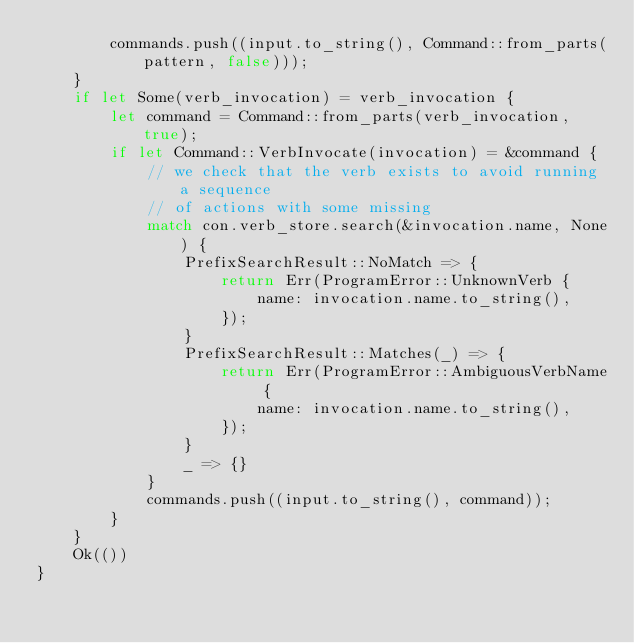<code> <loc_0><loc_0><loc_500><loc_500><_Rust_>        commands.push((input.to_string(), Command::from_parts(pattern, false)));
    }
    if let Some(verb_invocation) = verb_invocation {
        let command = Command::from_parts(verb_invocation, true);
        if let Command::VerbInvocate(invocation) = &command {
            // we check that the verb exists to avoid running a sequence
            // of actions with some missing
            match con.verb_store.search(&invocation.name, None) {
                PrefixSearchResult::NoMatch => {
                    return Err(ProgramError::UnknownVerb {
                        name: invocation.name.to_string(),
                    });
                }
                PrefixSearchResult::Matches(_) => {
                    return Err(ProgramError::AmbiguousVerbName {
                        name: invocation.name.to_string(),
                    });
                }
                _ => {}
            }
            commands.push((input.to_string(), command));
        }
    }
    Ok(())
}
</code> 